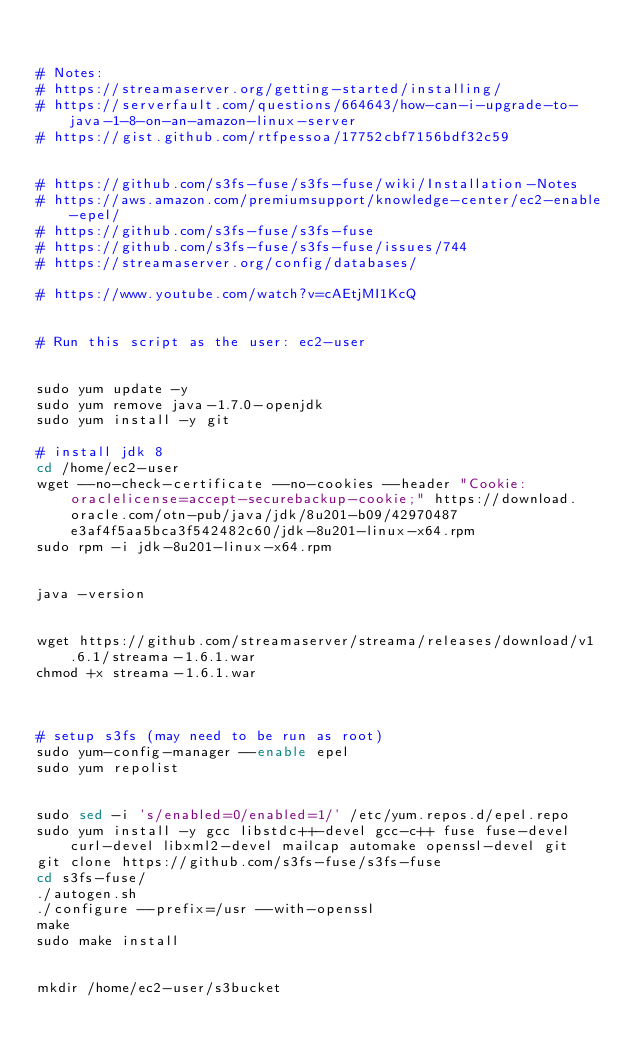<code> <loc_0><loc_0><loc_500><loc_500><_Bash_>

# Notes:
# https://streamaserver.org/getting-started/installing/
# https://serverfault.com/questions/664643/how-can-i-upgrade-to-java-1-8-on-an-amazon-linux-server
# https://gist.github.com/rtfpessoa/17752cbf7156bdf32c59


# https://github.com/s3fs-fuse/s3fs-fuse/wiki/Installation-Notes
# https://aws.amazon.com/premiumsupport/knowledge-center/ec2-enable-epel/
# https://github.com/s3fs-fuse/s3fs-fuse
# https://github.com/s3fs-fuse/s3fs-fuse/issues/744
# https://streamaserver.org/config/databases/

# https://www.youtube.com/watch?v=cAEtjMI1KcQ


# Run this script as the user: ec2-user


sudo yum update -y
sudo yum remove java-1.7.0-openjdk
sudo yum install -y git

# install jdk 8
cd /home/ec2-user
wget --no-check-certificate --no-cookies --header "Cookie: oraclelicense=accept-securebackup-cookie;" https://download.oracle.com/otn-pub/java/jdk/8u201-b09/42970487e3af4f5aa5bca3f542482c60/jdk-8u201-linux-x64.rpm
sudo rpm -i jdk-8u201-linux-x64.rpm 


java -version


wget https://github.com/streamaserver/streama/releases/download/v1.6.1/streama-1.6.1.war
chmod +x streama-1.6.1.war



# setup s3fs (may need to be run as root)
sudo yum-config-manager --enable epel
sudo yum repolist


sudo sed -i 's/enabled=0/enabled=1/' /etc/yum.repos.d/epel.repo
sudo yum install -y gcc libstdc++-devel gcc-c++ fuse fuse-devel curl-devel libxml2-devel mailcap automake openssl-devel git
git clone https://github.com/s3fs-fuse/s3fs-fuse
cd s3fs-fuse/
./autogen.sh
./configure --prefix=/usr --with-openssl
make
sudo make install


mkdir /home/ec2-user/s3bucket</code> 